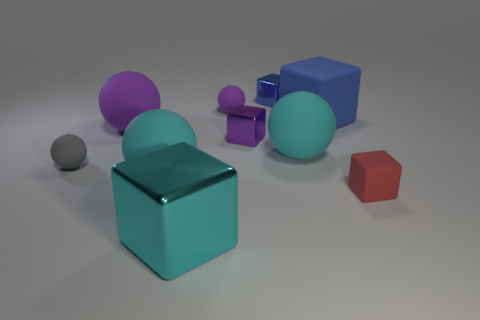Is the tiny blue thing made of the same material as the big blue object?
Make the answer very short. No. How many small purple things are the same material as the tiny purple ball?
Provide a succinct answer. 0. Does the gray rubber object have the same size as the purple rubber thing in front of the blue rubber cube?
Ensure brevity in your answer.  No. The tiny matte thing that is on the right side of the large cyan block and behind the red block is what color?
Your response must be concise. Purple. There is a cyan matte sphere left of the cyan shiny block; are there any balls that are left of it?
Keep it short and to the point. Yes. Is the number of big blue objects that are on the left side of the small blue metal cube the same as the number of big red shiny balls?
Give a very brief answer. Yes. What number of blue things are in front of the small blue metal object behind the red thing behind the big cyan metal thing?
Provide a succinct answer. 1. Are there any yellow metal blocks that have the same size as the red cube?
Your response must be concise. No. Is the number of cyan matte balls that are on the right side of the small blue thing less than the number of blue cubes?
Your answer should be compact. Yes. The cyan thing that is in front of the cyan rubber object that is on the left side of the ball to the right of the small purple matte sphere is made of what material?
Your response must be concise. Metal. 